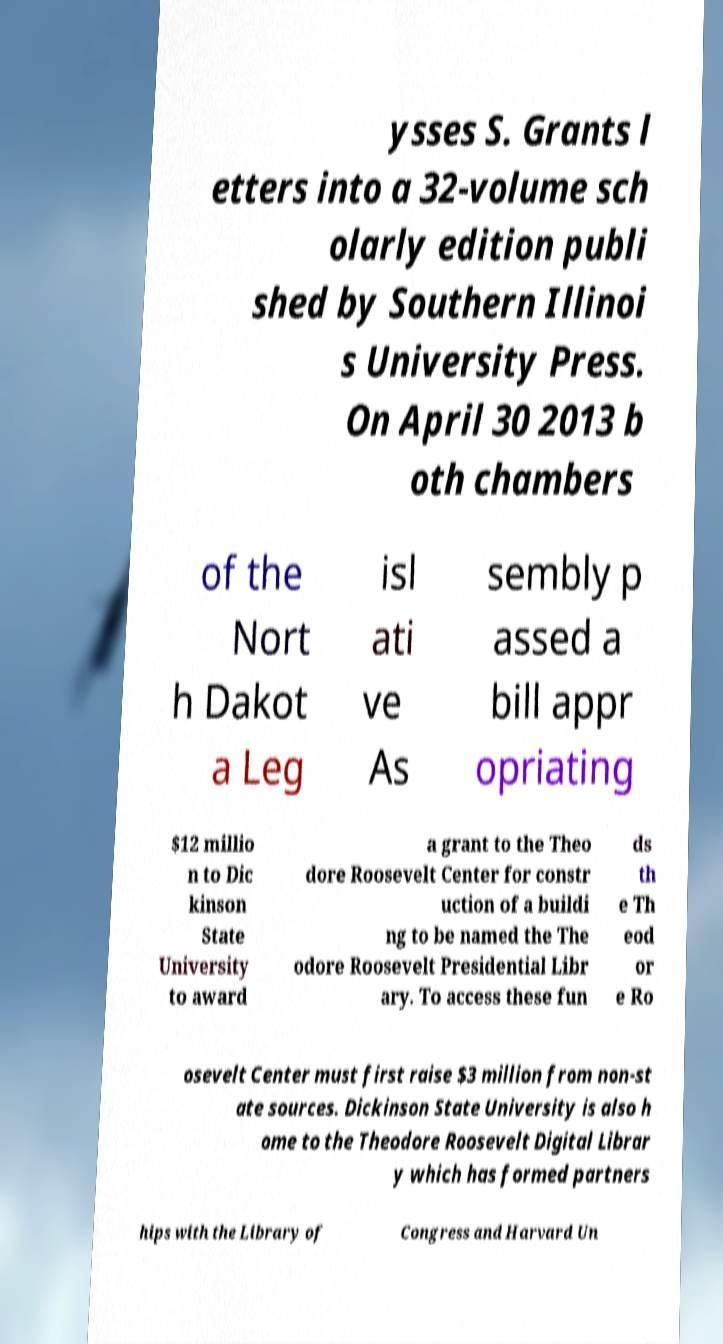Can you read and provide the text displayed in the image?This photo seems to have some interesting text. Can you extract and type it out for me? ysses S. Grants l etters into a 32-volume sch olarly edition publi shed by Southern Illinoi s University Press. On April 30 2013 b oth chambers of the Nort h Dakot a Leg isl ati ve As sembly p assed a bill appr opriating $12 millio n to Dic kinson State University to award a grant to the Theo dore Roosevelt Center for constr uction of a buildi ng to be named the The odore Roosevelt Presidential Libr ary. To access these fun ds th e Th eod or e Ro osevelt Center must first raise $3 million from non-st ate sources. Dickinson State University is also h ome to the Theodore Roosevelt Digital Librar y which has formed partners hips with the Library of Congress and Harvard Un 